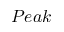Convert formula to latex. <formula><loc_0><loc_0><loc_500><loc_500>P e a k</formula> 